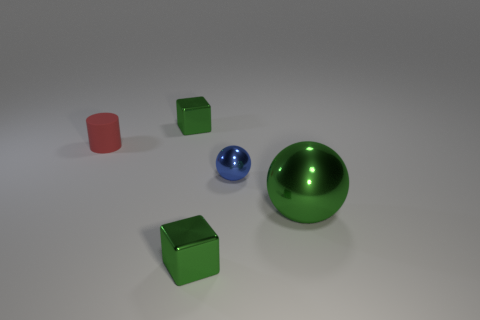Is the number of big green things greater than the number of cyan rubber things?
Your response must be concise. Yes. Does the sphere in front of the blue sphere have the same material as the tiny red cylinder that is behind the large metal ball?
Offer a very short reply. No. What material is the big green ball?
Make the answer very short. Metal. Are there more small red matte objects in front of the red thing than small things?
Give a very brief answer. No. There is a metallic block that is in front of the thing that is behind the rubber thing; what number of tiny green blocks are on the left side of it?
Offer a very short reply. 1. The cylinder has what color?
Provide a short and direct response. Red. Is the number of tiny things behind the blue shiny ball greater than the number of metallic things that are behind the small rubber object?
Your answer should be very brief. Yes. There is a object that is behind the small cylinder; what is its color?
Provide a succinct answer. Green. Is the size of the green metallic block that is in front of the tiny blue metal thing the same as the green block behind the small sphere?
Make the answer very short. Yes. How many things are either tiny blue metal things or tiny yellow rubber cylinders?
Your answer should be very brief. 1. 